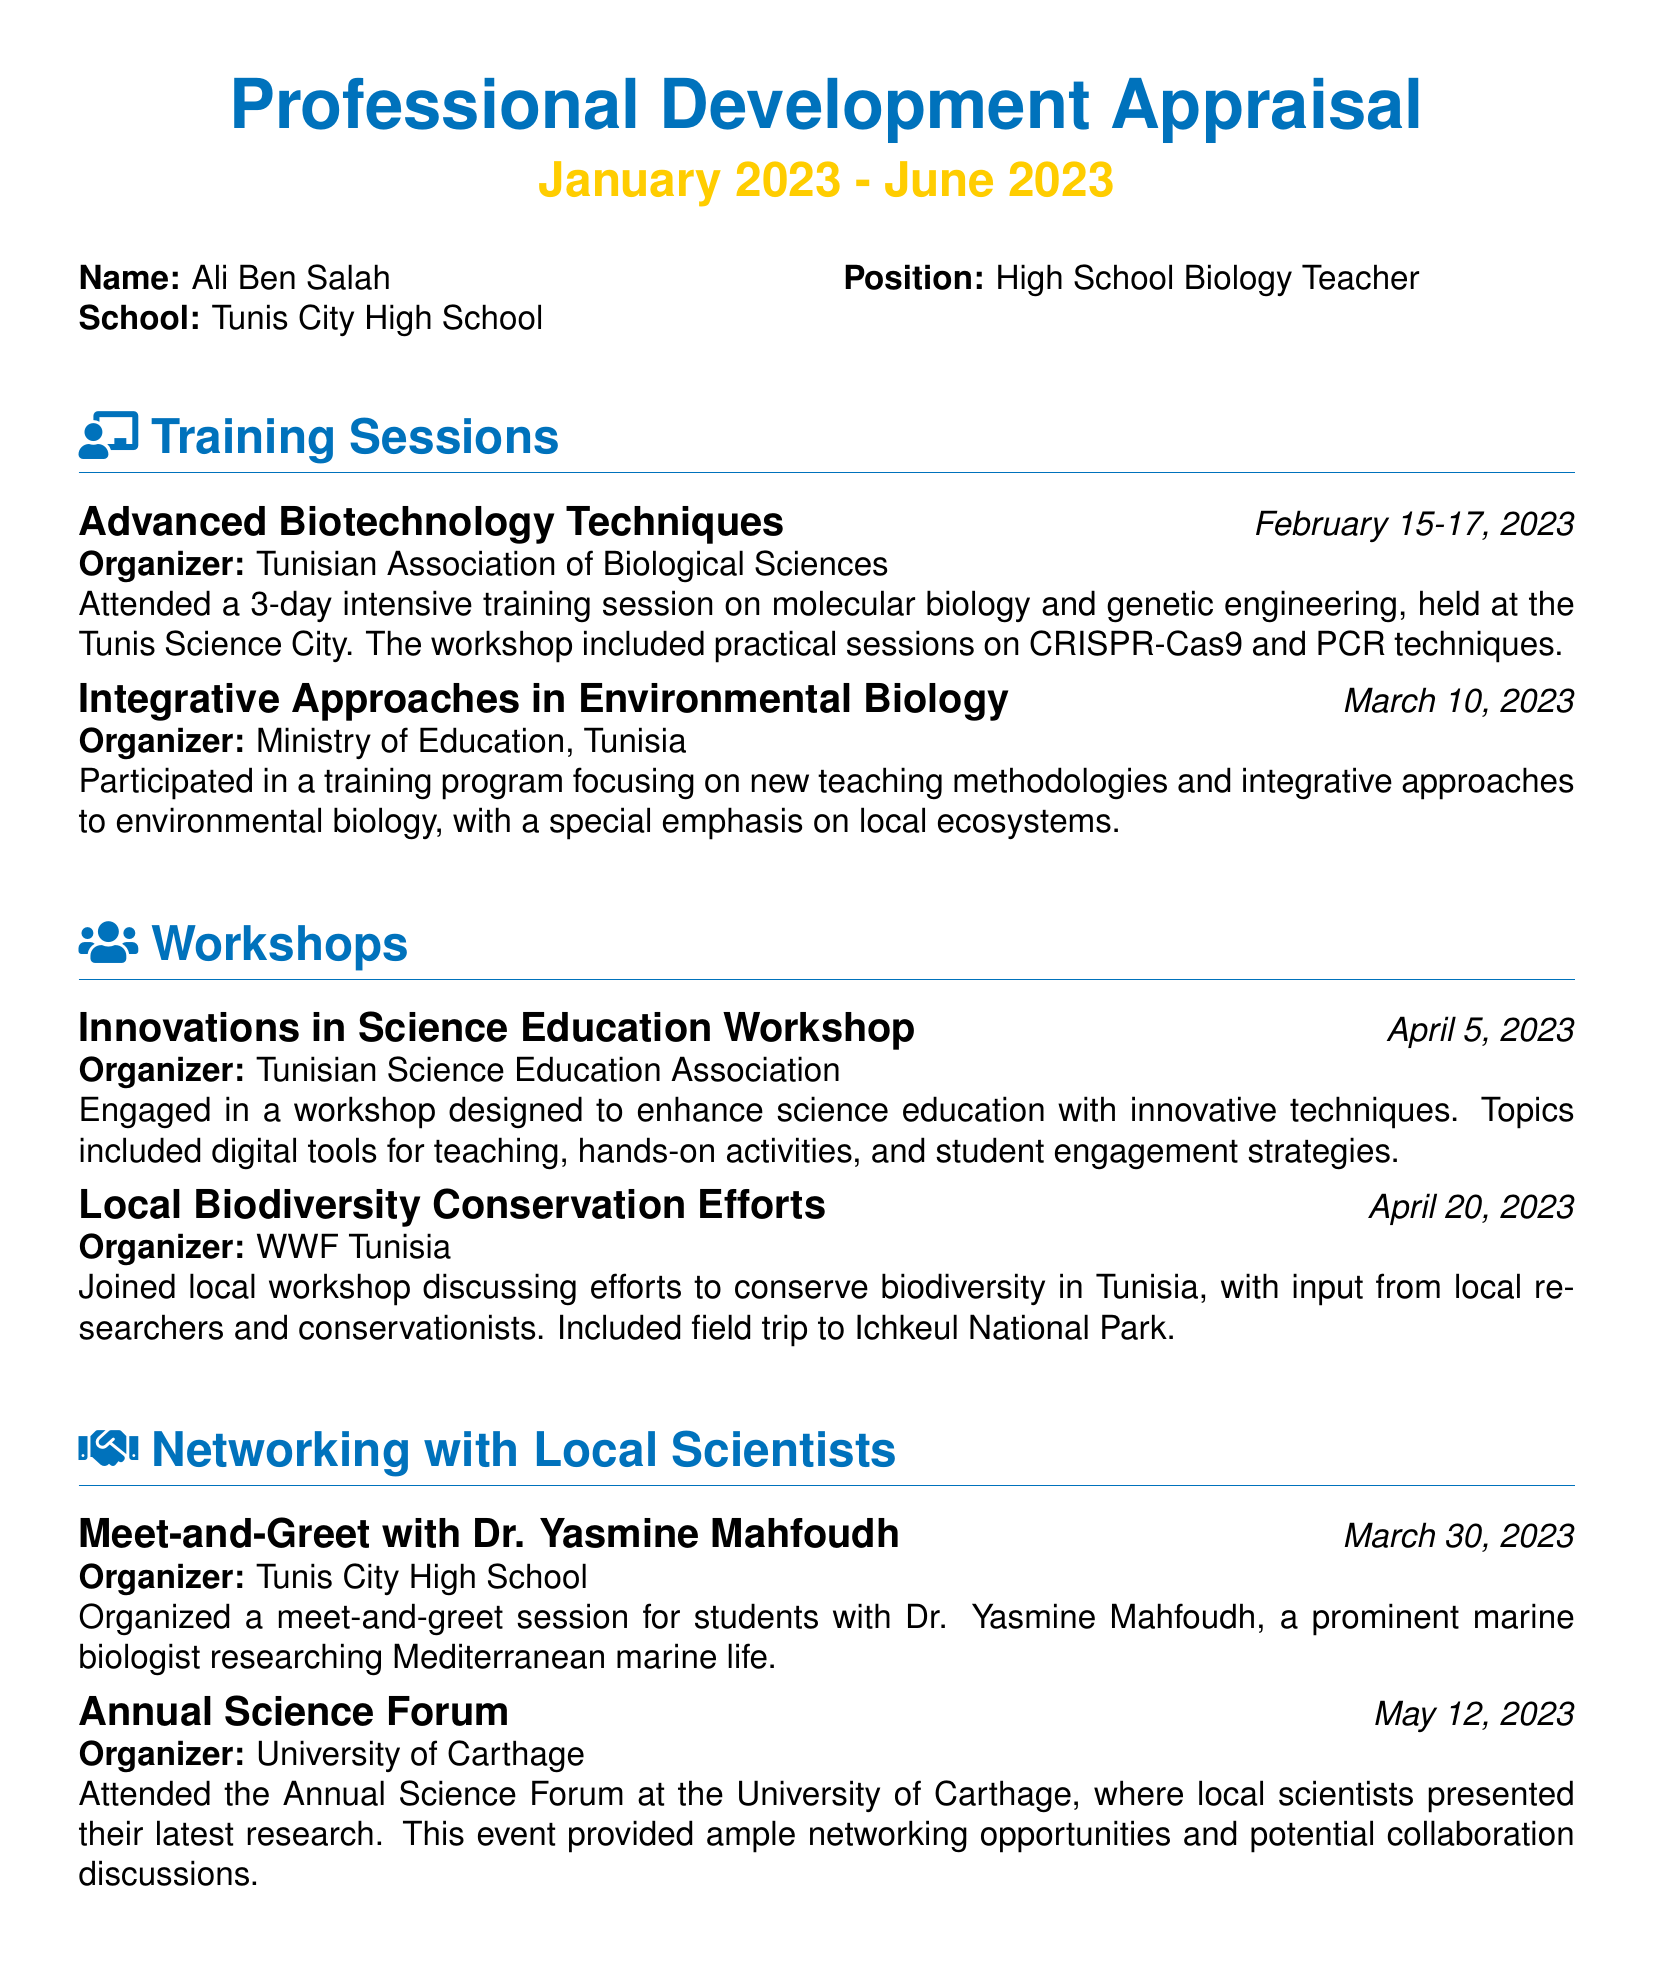What is the name of the teacher? The teacher's name is listed in the document as Ali Ben Salah.
Answer: Ali Ben Salah What position does Ali Ben Salah hold? The document states that he is a High School Biology Teacher.
Answer: High School Biology Teacher When did the advanced biotechnology techniques training take place? The date of the training is provided as February 15-17, 2023.
Answer: February 15-17, 2023 Which organization hosted the innovations in science education workshop? The workshop is organized by the Tunisian Science Education Association.
Answer: Tunisian Science Education Association What was the focus of the training program attended on March 10, 2023? The focus of the program was on new teaching methodologies and integrative approaches to environmental biology.
Answer: New teaching methodologies and integrative approaches to environmental biology Who was the local scientist met during the meet-and-greet session? The local scientist mentioned in the document is Dr. Yasmine Mahfoudh.
Answer: Dr. Yasmine Mahfoudh How many days was the training session on advanced biotechnology? The training session lasted for 3 days.
Answer: 3 days Where did the Annual Science Forum take place? The forum was held at the University of Carthage.
Answer: University of Carthage What was included in the local biodiversity conservation workshop? The workshop included a field trip to Ichkeul National Park.
Answer: Field trip to Ichkeul National Park 